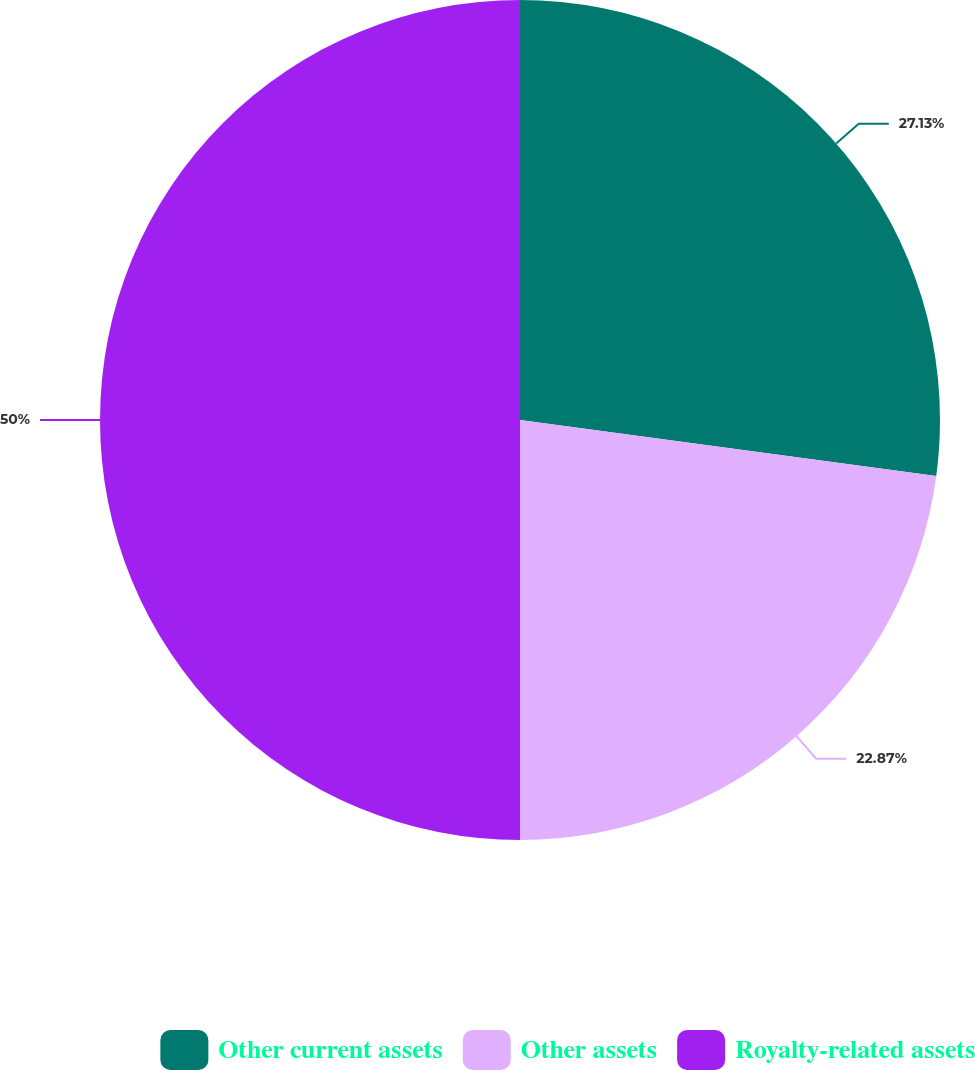Convert chart. <chart><loc_0><loc_0><loc_500><loc_500><pie_chart><fcel>Other current assets<fcel>Other assets<fcel>Royalty-related assets<nl><fcel>27.13%<fcel>22.87%<fcel>50.0%<nl></chart> 